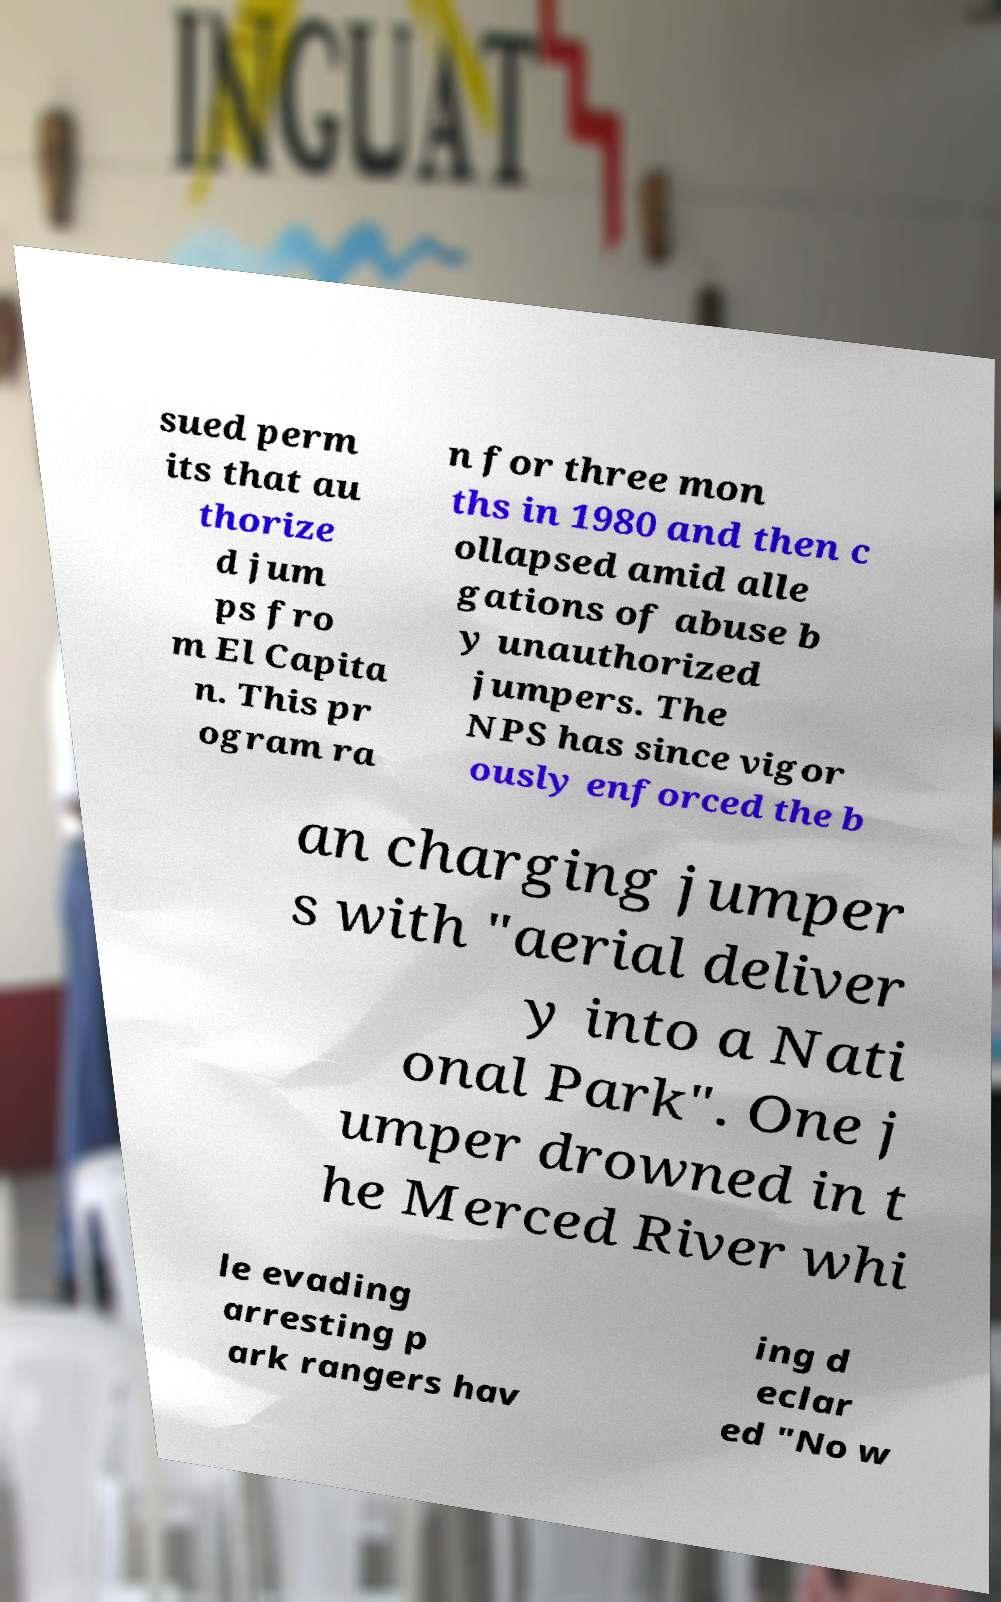What messages or text are displayed in this image? I need them in a readable, typed format. sued perm its that au thorize d jum ps fro m El Capita n. This pr ogram ra n for three mon ths in 1980 and then c ollapsed amid alle gations of abuse b y unauthorized jumpers. The NPS has since vigor ously enforced the b an charging jumper s with "aerial deliver y into a Nati onal Park". One j umper drowned in t he Merced River whi le evading arresting p ark rangers hav ing d eclar ed "No w 